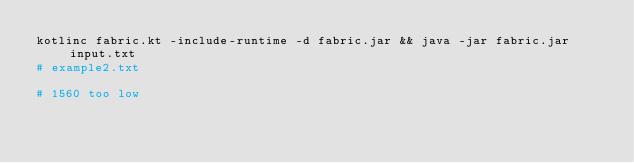Convert code to text. <code><loc_0><loc_0><loc_500><loc_500><_Bash_>kotlinc fabric.kt -include-runtime -d fabric.jar && java -jar fabric.jar input.txt
# example2.txt

# 1560 too low
</code> 